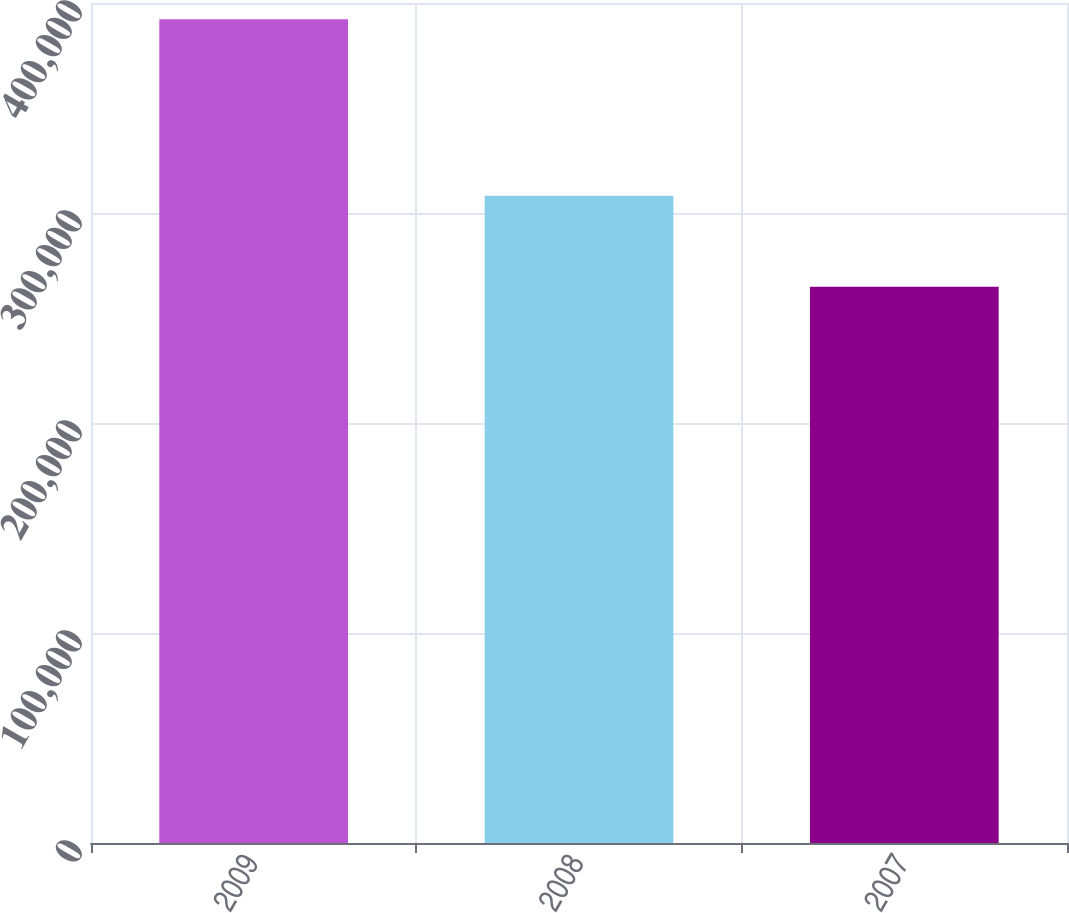Convert chart. <chart><loc_0><loc_0><loc_500><loc_500><bar_chart><fcel>2009<fcel>2008<fcel>2007<nl><fcel>392236<fcel>308260<fcel>264931<nl></chart> 